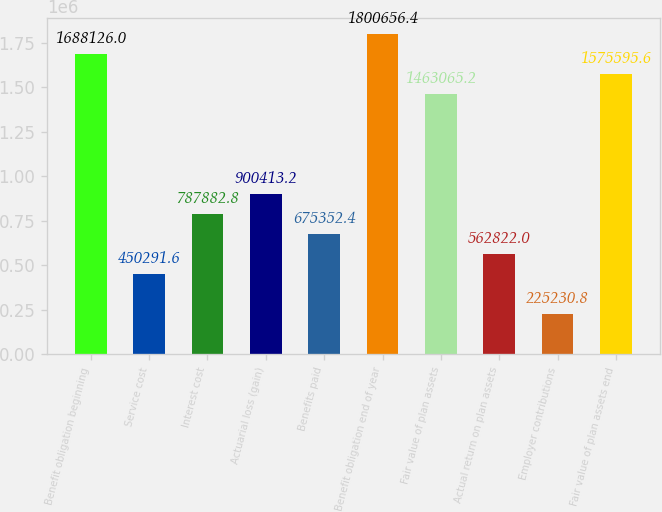<chart> <loc_0><loc_0><loc_500><loc_500><bar_chart><fcel>Benefit obligation beginning<fcel>Service cost<fcel>Interest cost<fcel>Actuarial loss (gain)<fcel>Benefits paid<fcel>Benefit obligation end of year<fcel>Fair value of plan assets<fcel>Actual return on plan assets<fcel>Employer contributions<fcel>Fair value of plan assets end<nl><fcel>1.68813e+06<fcel>450292<fcel>787883<fcel>900413<fcel>675352<fcel>1.80066e+06<fcel>1.46307e+06<fcel>562822<fcel>225231<fcel>1.5756e+06<nl></chart> 